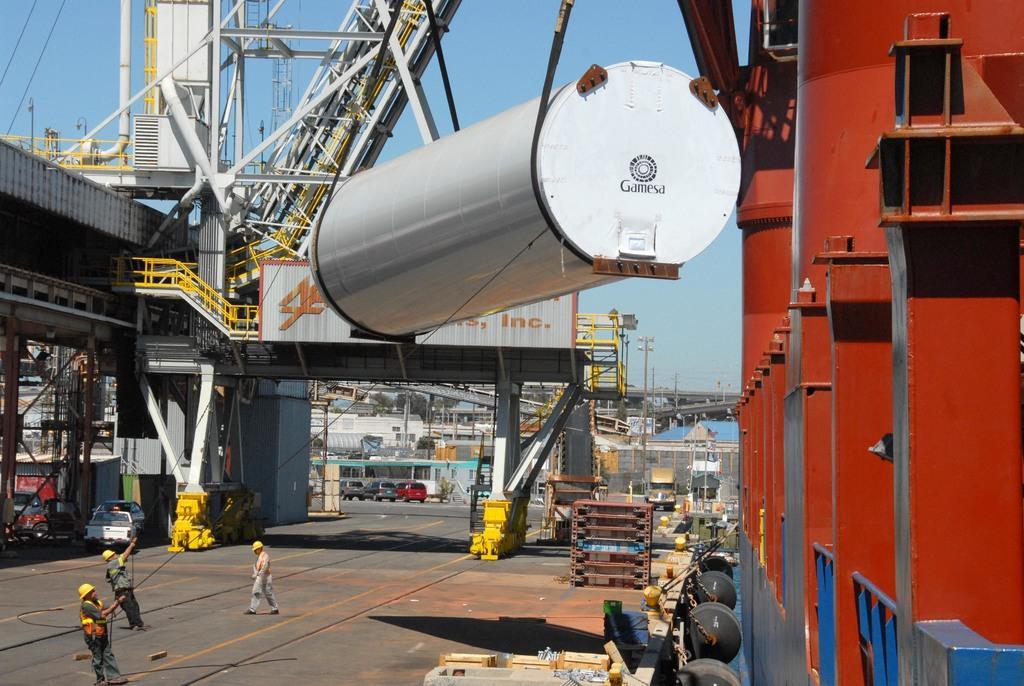Could you give a brief overview of what you see in this image? In this picture I can see the factory. In the bottom left corner there are two persons who are holding the ropes and this ropes are connected to this round white color object. Beside them there is a man who is a walking on the road. On the right I can see the red color steel structures. On the left I can see some vehicles which are parked near to the shed. At the top I can see the sky. 